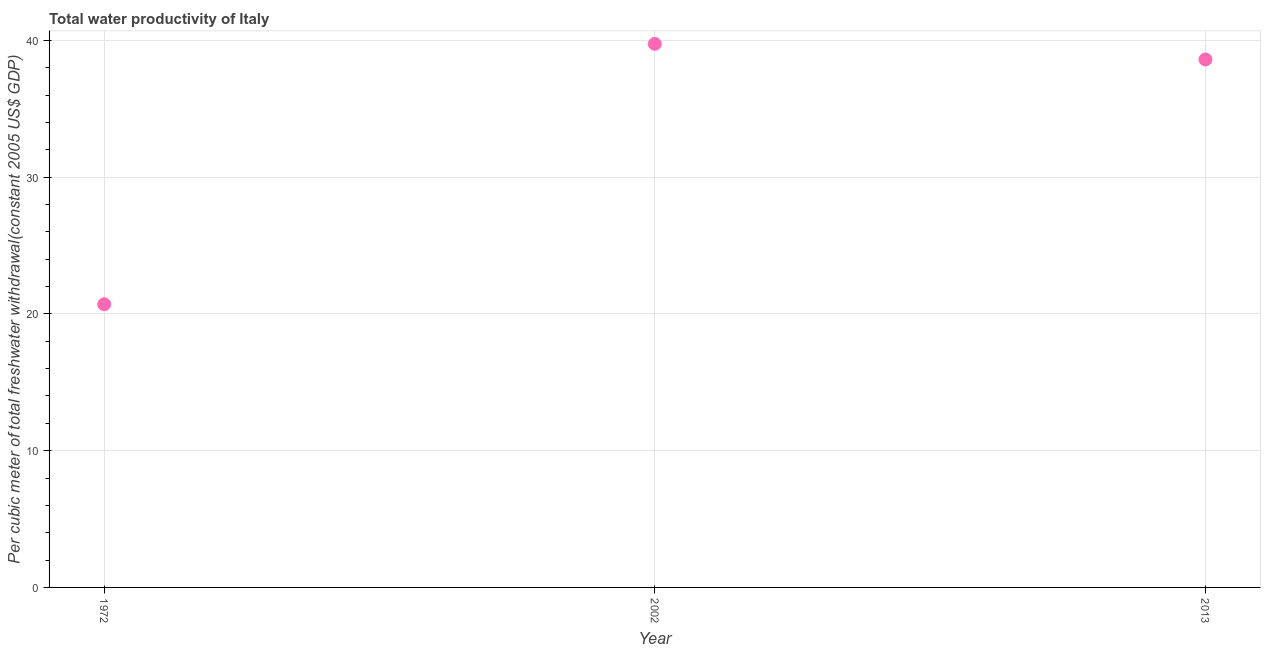What is the total water productivity in 2013?
Your response must be concise. 38.6. Across all years, what is the maximum total water productivity?
Give a very brief answer. 39.74. Across all years, what is the minimum total water productivity?
Provide a succinct answer. 20.7. In which year was the total water productivity minimum?
Provide a short and direct response. 1972. What is the sum of the total water productivity?
Make the answer very short. 99.05. What is the difference between the total water productivity in 1972 and 2013?
Provide a succinct answer. -17.9. What is the average total water productivity per year?
Give a very brief answer. 33.02. What is the median total water productivity?
Your answer should be very brief. 38.6. In how many years, is the total water productivity greater than 32 US$?
Ensure brevity in your answer.  2. What is the ratio of the total water productivity in 1972 to that in 2002?
Ensure brevity in your answer.  0.52. Is the total water productivity in 1972 less than that in 2002?
Your response must be concise. Yes. Is the difference between the total water productivity in 2002 and 2013 greater than the difference between any two years?
Your answer should be very brief. No. What is the difference between the highest and the second highest total water productivity?
Offer a terse response. 1.14. What is the difference between the highest and the lowest total water productivity?
Your response must be concise. 19.04. In how many years, is the total water productivity greater than the average total water productivity taken over all years?
Offer a very short reply. 2. Does the total water productivity monotonically increase over the years?
Your response must be concise. No. How many dotlines are there?
Offer a terse response. 1. What is the difference between two consecutive major ticks on the Y-axis?
Keep it short and to the point. 10. Are the values on the major ticks of Y-axis written in scientific E-notation?
Offer a terse response. No. Does the graph contain any zero values?
Your answer should be compact. No. What is the title of the graph?
Provide a succinct answer. Total water productivity of Italy. What is the label or title of the X-axis?
Provide a short and direct response. Year. What is the label or title of the Y-axis?
Your answer should be very brief. Per cubic meter of total freshwater withdrawal(constant 2005 US$ GDP). What is the Per cubic meter of total freshwater withdrawal(constant 2005 US$ GDP) in 1972?
Ensure brevity in your answer.  20.7. What is the Per cubic meter of total freshwater withdrawal(constant 2005 US$ GDP) in 2002?
Ensure brevity in your answer.  39.74. What is the Per cubic meter of total freshwater withdrawal(constant 2005 US$ GDP) in 2013?
Provide a short and direct response. 38.6. What is the difference between the Per cubic meter of total freshwater withdrawal(constant 2005 US$ GDP) in 1972 and 2002?
Offer a terse response. -19.04. What is the difference between the Per cubic meter of total freshwater withdrawal(constant 2005 US$ GDP) in 1972 and 2013?
Your answer should be very brief. -17.9. What is the difference between the Per cubic meter of total freshwater withdrawal(constant 2005 US$ GDP) in 2002 and 2013?
Provide a succinct answer. 1.14. What is the ratio of the Per cubic meter of total freshwater withdrawal(constant 2005 US$ GDP) in 1972 to that in 2002?
Make the answer very short. 0.52. What is the ratio of the Per cubic meter of total freshwater withdrawal(constant 2005 US$ GDP) in 1972 to that in 2013?
Your answer should be very brief. 0.54. What is the ratio of the Per cubic meter of total freshwater withdrawal(constant 2005 US$ GDP) in 2002 to that in 2013?
Give a very brief answer. 1.03. 